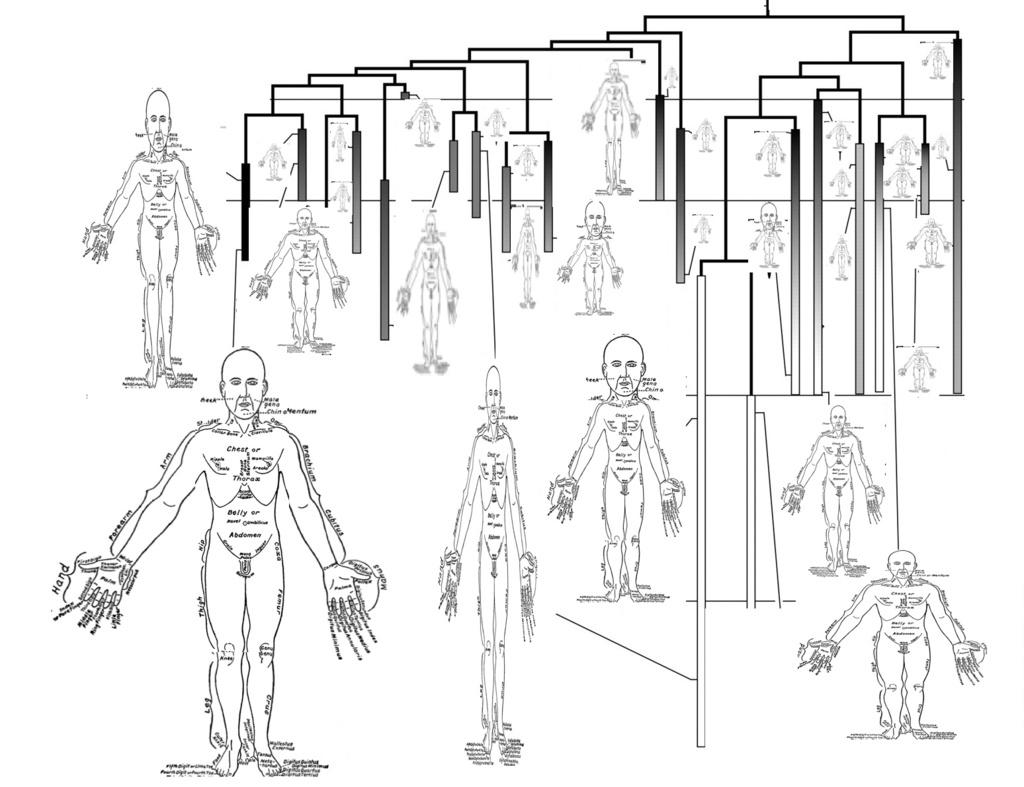What is the main subject of the image? The main subject of the image is a structure of a human body. Can you describe the structure in more detail? Unfortunately, the provided facts do not offer any additional details about the structure. How many sacks are being carried by the sisters in the image? There are no sisters or sacks present in the image; it only features a structure of a human body. 